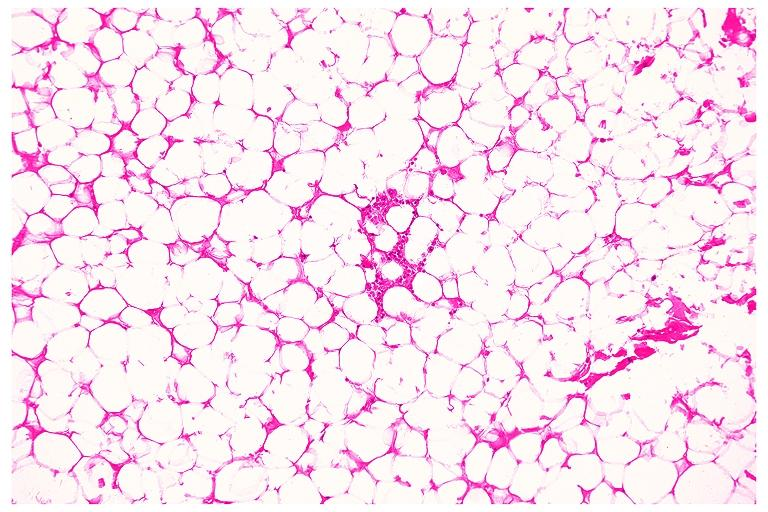s oral present?
Answer the question using a single word or phrase. Yes 